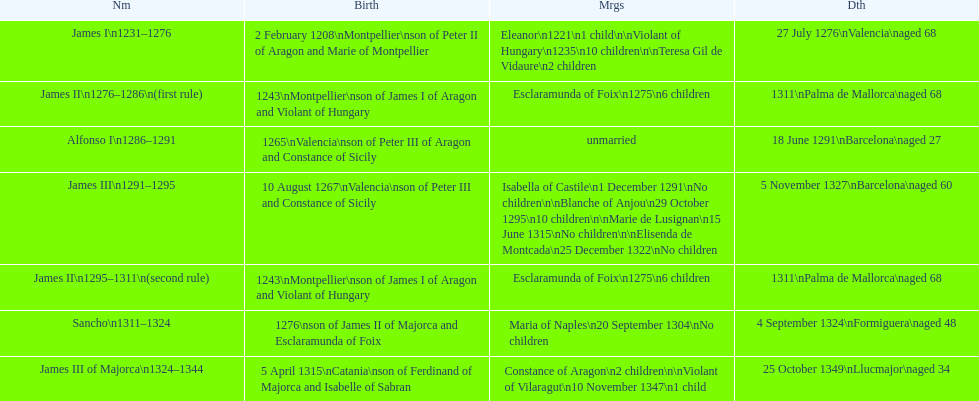Who came to power after the rule of james iii? James II. 